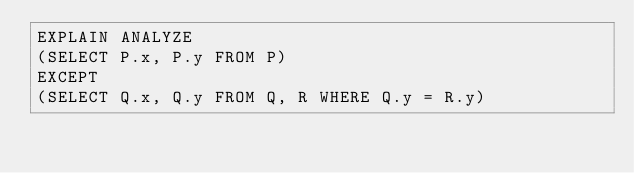Convert code to text. <code><loc_0><loc_0><loc_500><loc_500><_SQL_>EXPLAIN ANALYZE
(SELECT P.x, P.y FROM P)
EXCEPT
(SELECT Q.x, Q.y FROM Q, R WHERE Q.y = R.y)
</code> 